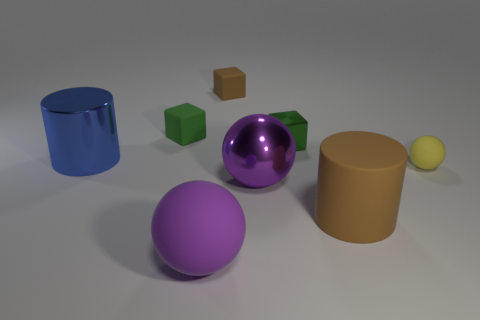How big is the green metallic thing?
Ensure brevity in your answer.  Small. There is a cylinder right of the large purple matte ball; how many purple things are behind it?
Keep it short and to the point. 1. There is a rubber thing that is both to the left of the tiny metallic cube and in front of the green metallic object; what shape is it?
Keep it short and to the point. Sphere. What number of matte spheres are the same color as the small shiny block?
Provide a short and direct response. 0. Is there a rubber ball that is in front of the small green cube to the right of the big shiny object that is in front of the yellow rubber object?
Your answer should be compact. Yes. There is a rubber object that is both right of the brown rubber cube and behind the large matte cylinder; what is its size?
Keep it short and to the point. Small. What number of large cylinders have the same material as the big brown thing?
Your answer should be very brief. 0. How many balls are tiny green matte things or large objects?
Your answer should be compact. 2. What is the size of the brown object behind the rubber ball that is behind the purple object that is left of the purple shiny ball?
Offer a terse response. Small. The rubber object that is both on the left side of the brown cylinder and in front of the large purple metallic object is what color?
Ensure brevity in your answer.  Purple. 